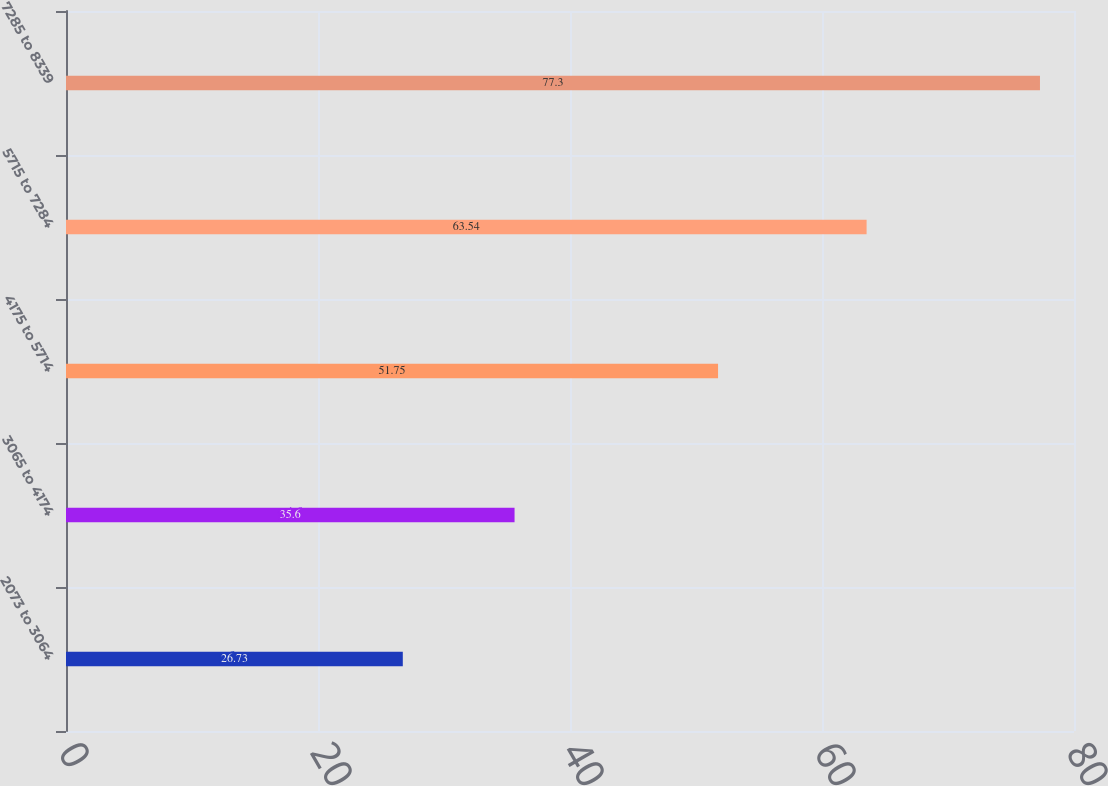Convert chart. <chart><loc_0><loc_0><loc_500><loc_500><bar_chart><fcel>2073 to 3064<fcel>3065 to 4174<fcel>4175 to 5714<fcel>5715 to 7284<fcel>7285 to 8339<nl><fcel>26.73<fcel>35.6<fcel>51.75<fcel>63.54<fcel>77.3<nl></chart> 